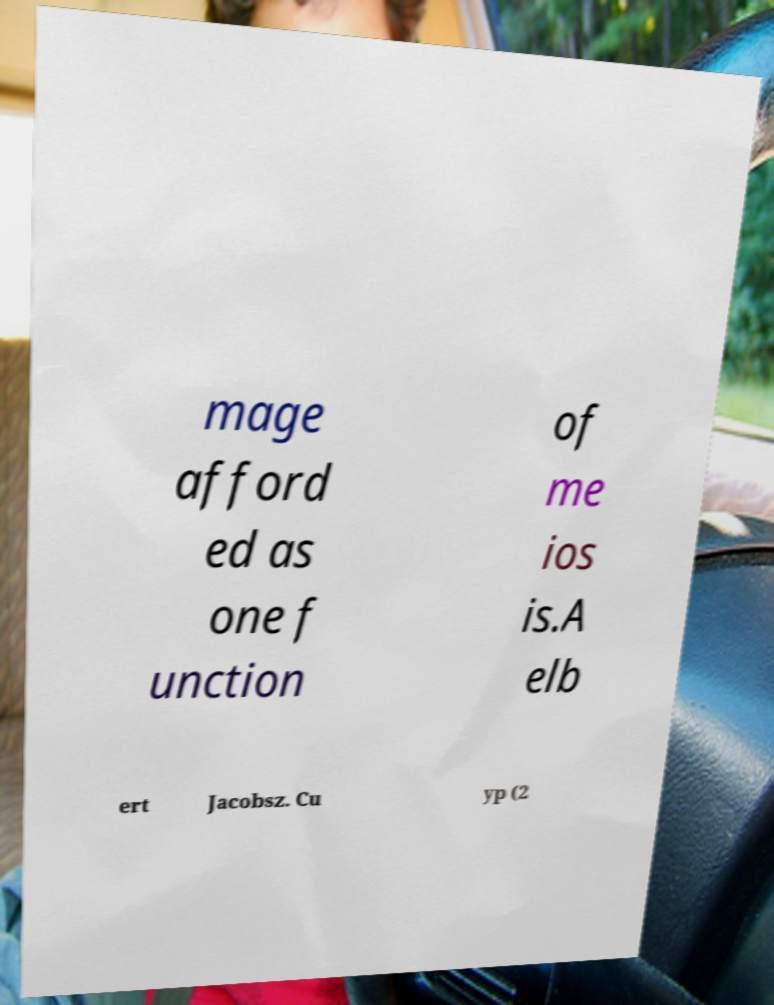Please identify and transcribe the text found in this image. mage afford ed as one f unction of me ios is.A elb ert Jacobsz. Cu yp (2 